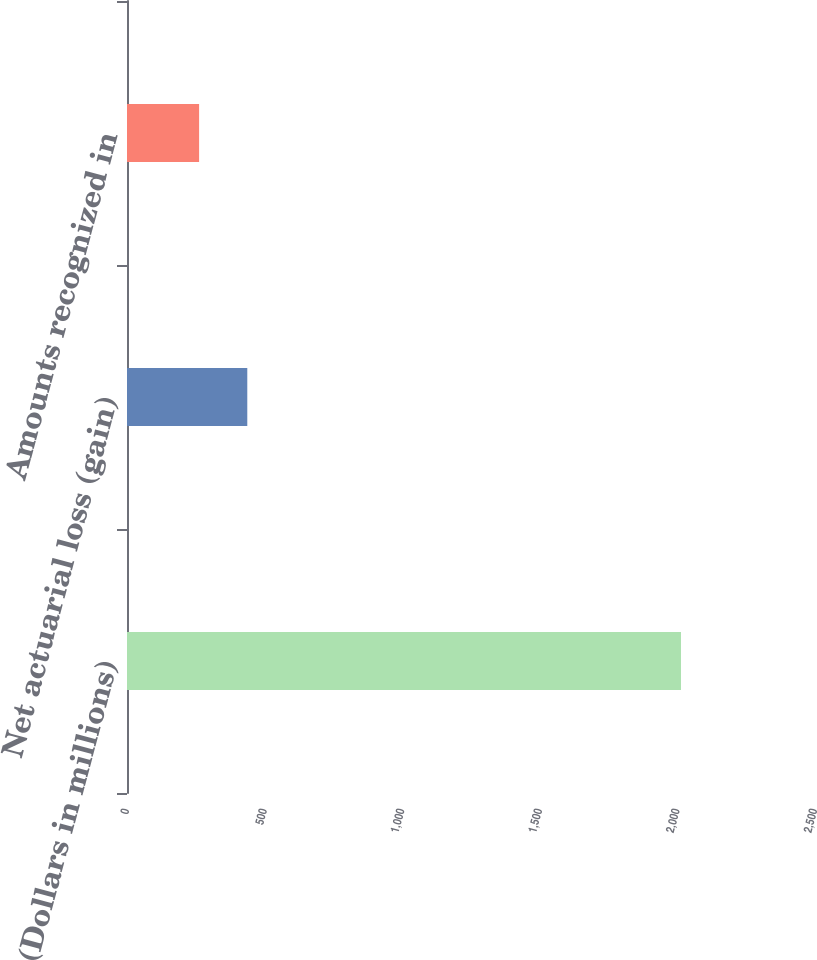Convert chart to OTSL. <chart><loc_0><loc_0><loc_500><loc_500><bar_chart><fcel>(Dollars in millions)<fcel>Net actuarial loss (gain)<fcel>Amounts recognized in<nl><fcel>2013<fcel>437.1<fcel>262<nl></chart> 